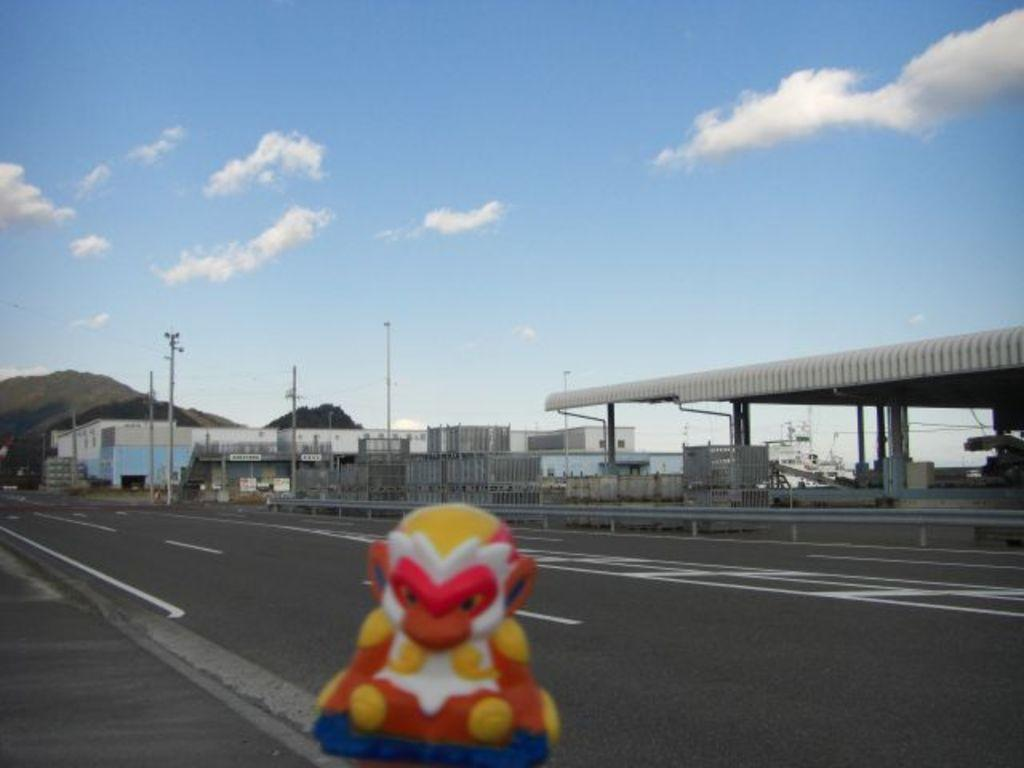What type of surface can be seen in the image? There is a road in the image. What distinguishing feature can be observed on the road? White lines are present on the road. What object is not related to the road or infrastructure in the image? There is a toy in the image. What structures are present near the road in the image? Electric poles and a light pole are visible in the image. What geographical feature is visible in the background of the image? There is a mountain in the image. What type of man-made structures are present in the image? Buildings are present in the image. How would you describe the weather condition in the image? The sky is cloudy in the image. How many beds are visible in the image? There are no beds present in the image. What type of spring is used in the image? There is no spring present in the image. 